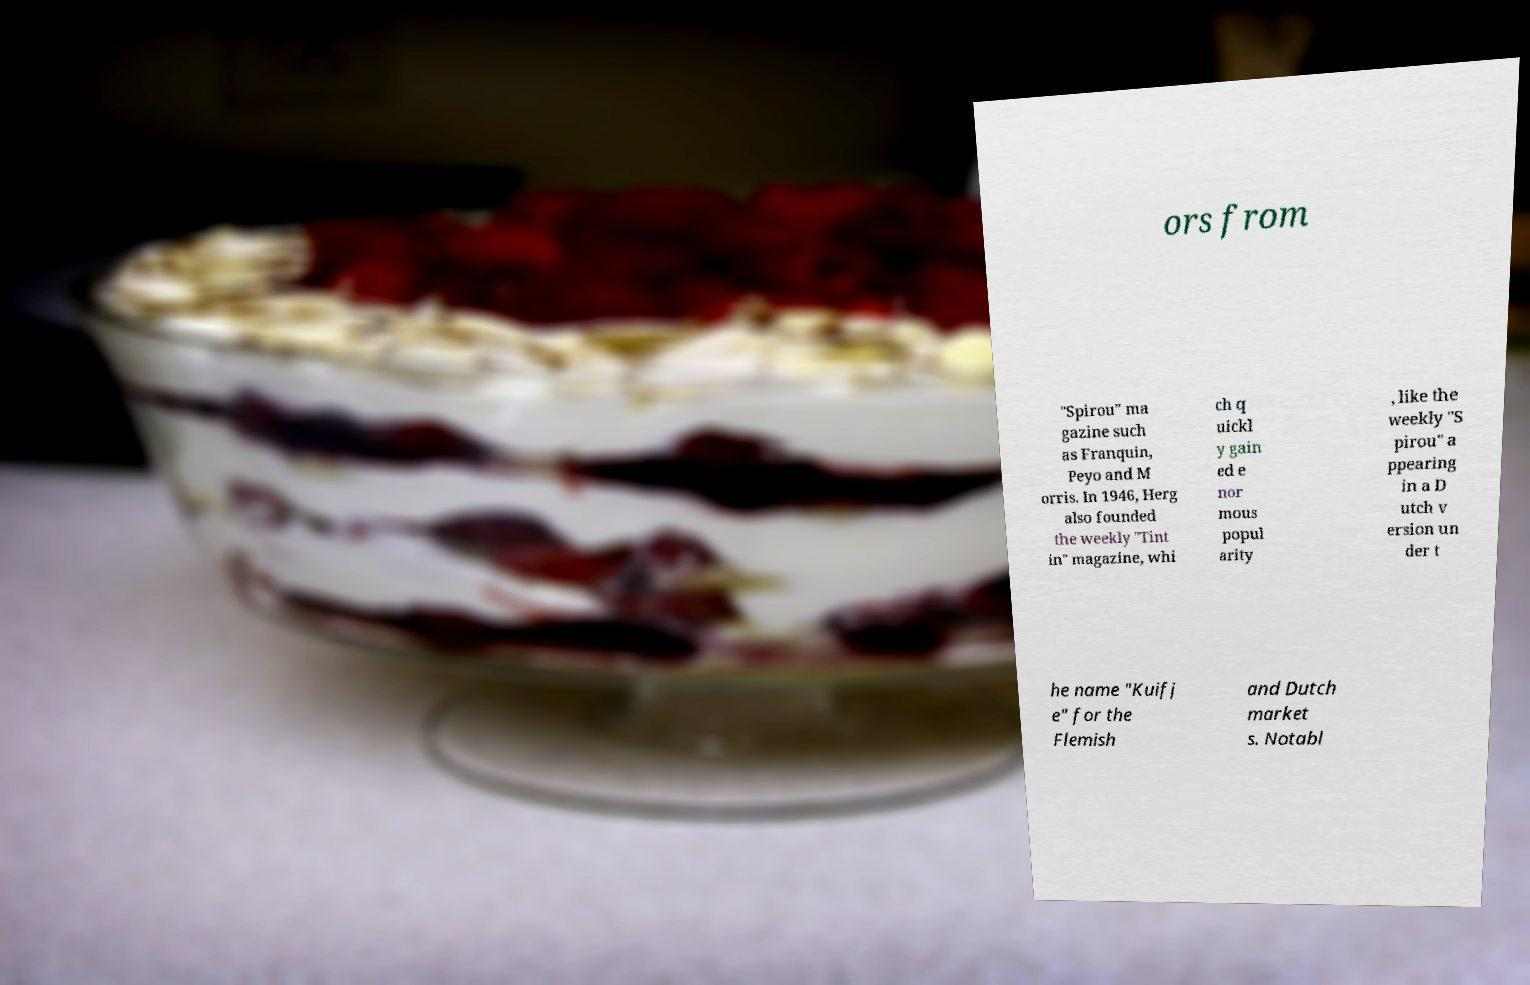Please identify and transcribe the text found in this image. ors from "Spirou" ma gazine such as Franquin, Peyo and M orris. In 1946, Herg also founded the weekly "Tint in" magazine, whi ch q uickl y gain ed e nor mous popul arity , like the weekly "S pirou" a ppearing in a D utch v ersion un der t he name "Kuifj e" for the Flemish and Dutch market s. Notabl 